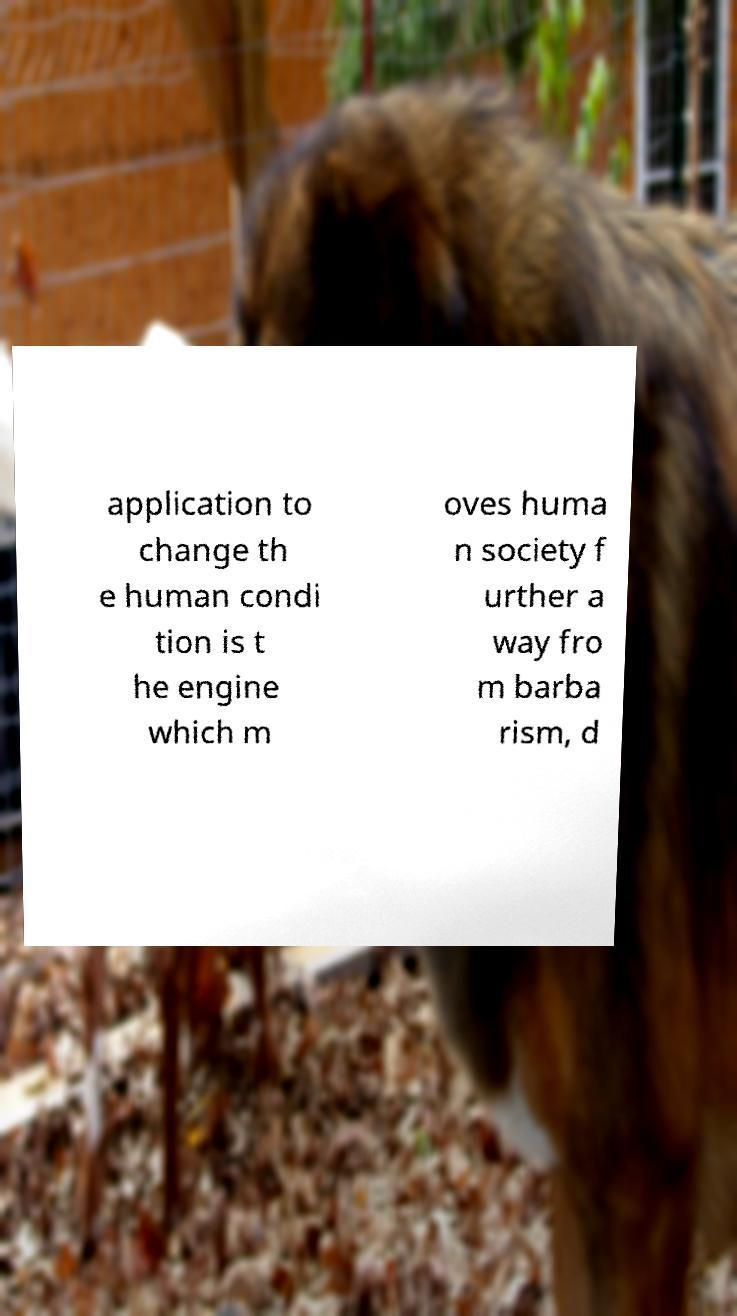Can you accurately transcribe the text from the provided image for me? application to change th e human condi tion is t he engine which m oves huma n society f urther a way fro m barba rism, d 